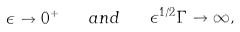<formula> <loc_0><loc_0><loc_500><loc_500>\epsilon \to 0 ^ { + } \quad a n d \quad \epsilon ^ { 1 / 2 } \Gamma \to \infty ,</formula> 